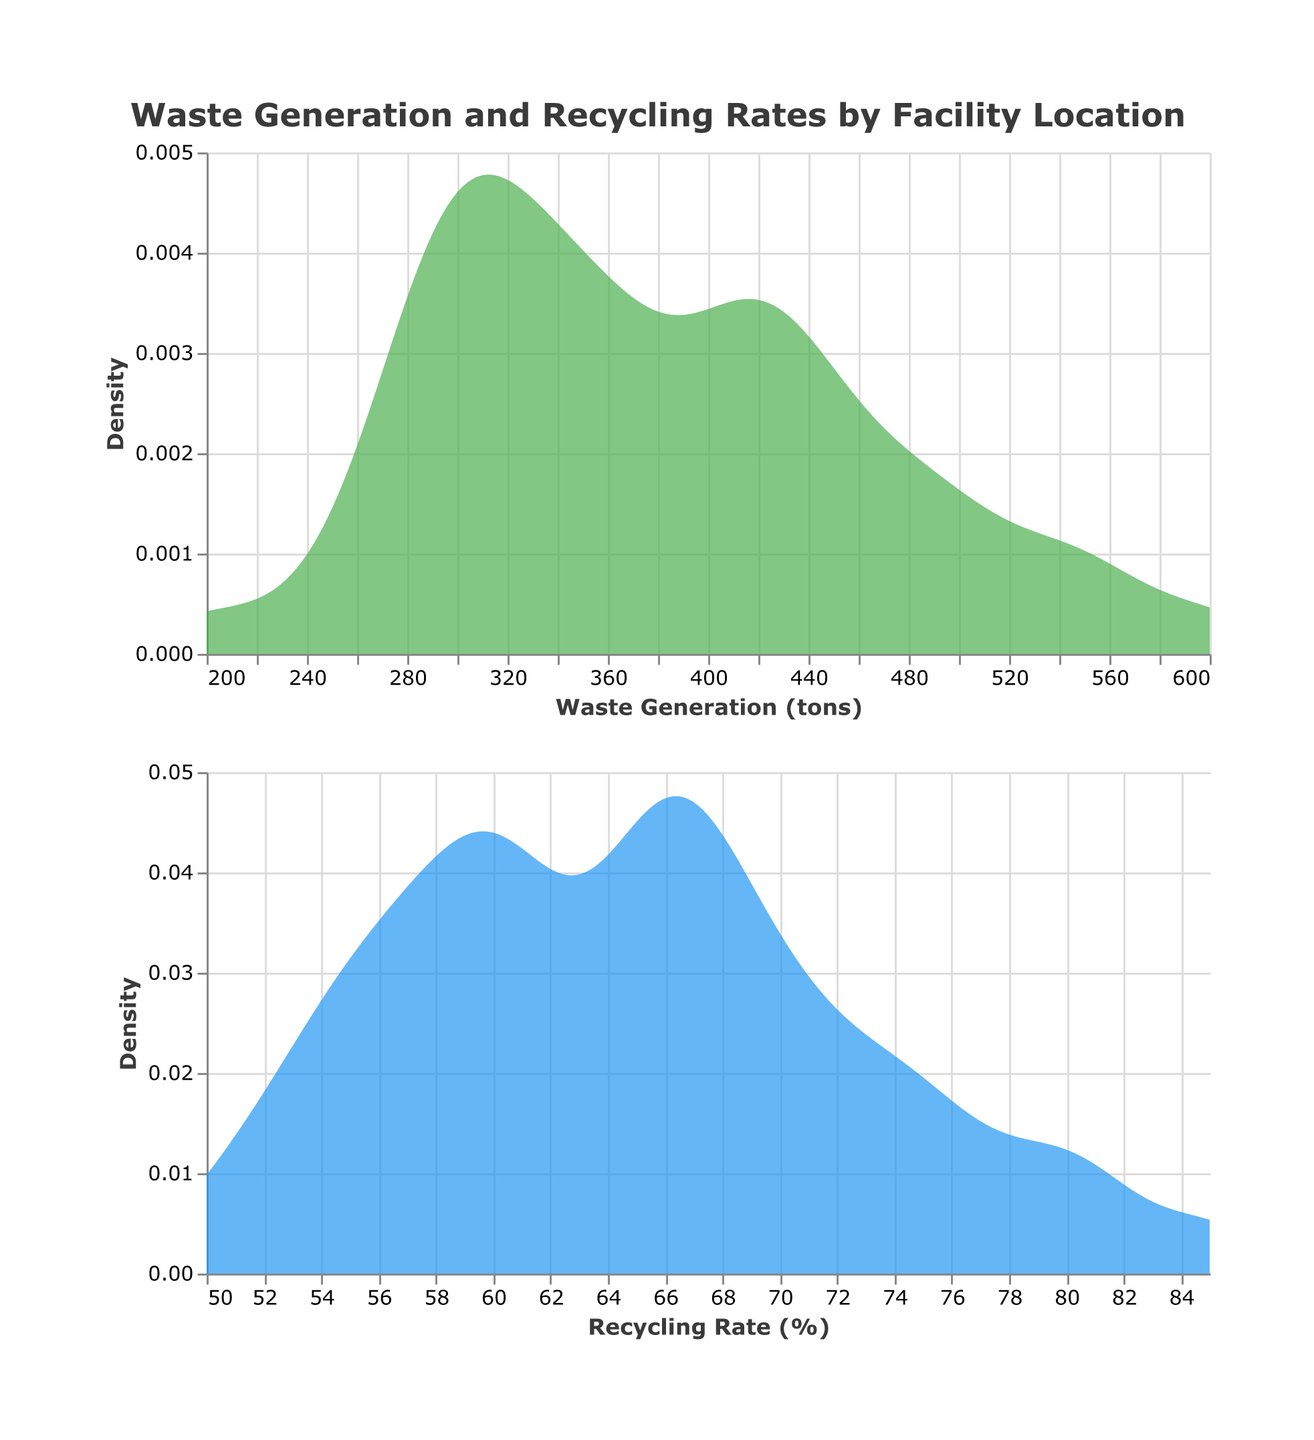What is the title of the figure? The title is prominently displayed at the top of the figure and provides a summary of what the figure is about.
Answer: Waste Generation and Recycling Rates by Facility Location What are the x-axis titles of the two subplots? The x-axis title describes what values are being represented horizontally in the density plots of each subplot. For the first subplot, it is "Waste Generation (tons)" and for the second subplot, it is "Recycling Rate (%)".
Answer: Waste Generation (tons), Recycling Rate (%) What colors are used for the two density plots? The colors used for the plots can be observed directly from the visual representation of the plots. The first density plot is a shade of green, and the second density plot is a shade of blue.
Answer: Green, Blue Which subplot shows higher recycling rates? The second subplot represents "Recycling Rate (%)", which directly shows the density distribution of recycling rates.
Answer: The second subplot What is the peak density value for "Waste Generation (tons)" and at approximately which value does it occur? The peak density value can be read off the y-axis of the first subplot, with the corresponding waste generation value on the x-axis. By observing the plot, the approximate peak density occurs around 400-450 tons.
Answer: Approximately 400-450 tons What is the range of the highest recycling density observed? The peak recycling density can be identified by the highest point on the second density plot and then mapped to the corresponding recycling rate on the x-axis, which occurs around 65-75%.
Answer: Approximately 65-75% How do the peaks of the density plots for "Waste Generation (tons)" and "Recycling Rate (%)" compare? By examining the highest points of the density plots in each subplot, one can compare the concentration of values. The waste generation plot peaks around 400-450 tons, while the recycling plot peaks around 65-75%.
Answer: Waste generation peaks around 400-450 tons; recycling rate peaks around 65-75% Is there a wider variability in "Waste Generation (tons)" or "Recycling Rate (%)"? By observing the width and spread of the density plots, one can infer variability. A wider plot implies a larger range of data values. The "Waste Generation (tons)" plot is broader, indicating greater variability.
Answer: Waste Generation (tons) Calculate the difference between the peak recycling rate and the lowest peak of waste generation density. The peak of the recycling rate density happens around 70%, and the lowest peak of the waste generation density is around 200-250 tons. This involves a direct comparison between identified peaks and troughs. The difference calculation involves subtracting the lowest peak of waste generation density from the peak recycling rate.
Answer: Approximately 70% - 200-250 tons 